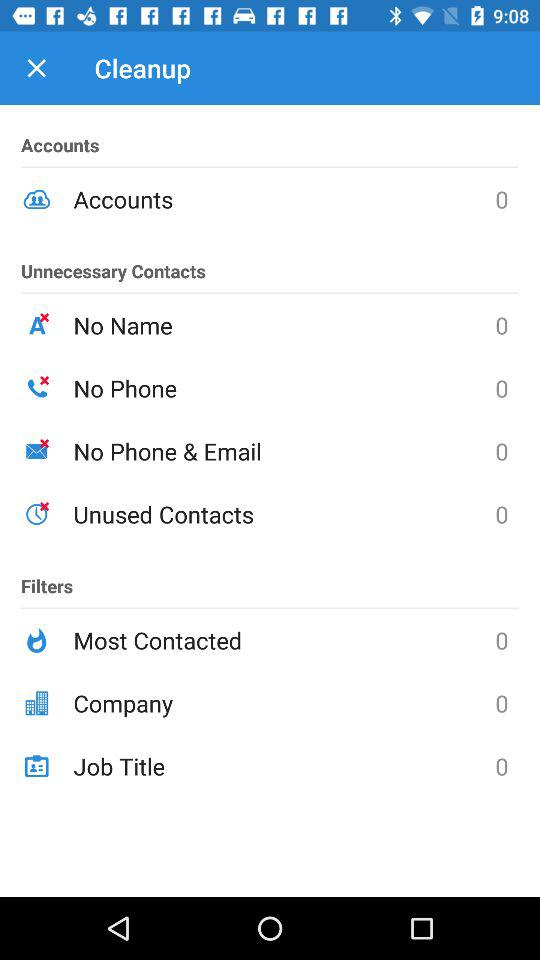What is the count for the company? The count for the company is 0. 